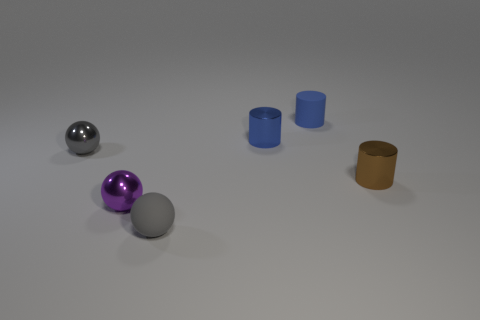Add 4 tiny blue matte things. How many objects exist? 10 Subtract 0 gray cubes. How many objects are left? 6 Subtract all rubber cylinders. Subtract all purple objects. How many objects are left? 4 Add 4 small spheres. How many small spheres are left? 7 Add 3 tiny blue metal things. How many tiny blue metal things exist? 4 